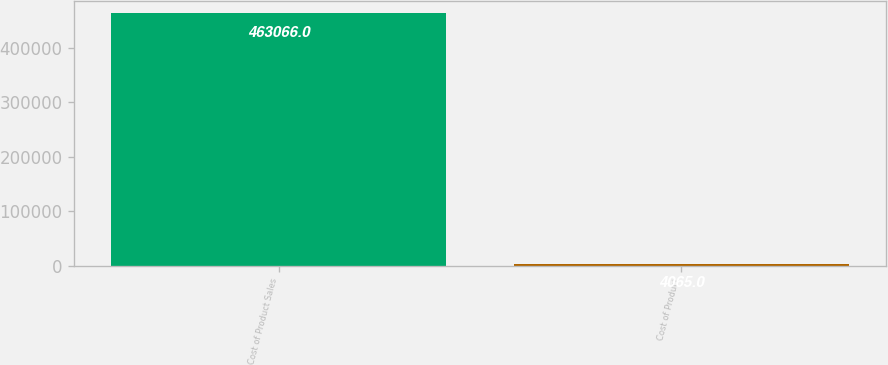Convert chart. <chart><loc_0><loc_0><loc_500><loc_500><bar_chart><fcel>Cost of Product Sales<fcel>Cost of Product<nl><fcel>463066<fcel>4065<nl></chart> 